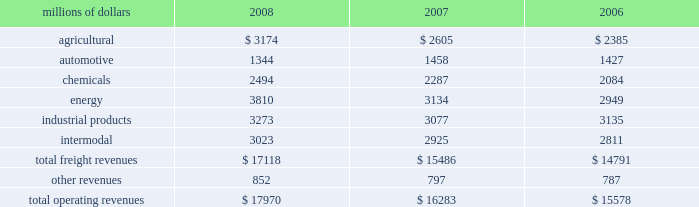Notes to the consolidated financial statements union pacific corporation and subsidiary companies for purposes of this report , unless the context otherwise requires , all references herein to the 201ccorporation 201d , 201cupc 201d , 201cwe 201d , 201cus 201d , and 201cour 201d mean union pacific corporation and its subsidiaries , including union pacific railroad company , which will be separately referred to herein as 201cuprr 201d or the 201crailroad 201d .
Nature of operations and significant accounting policies operations and segmentation 2013 we are a class i railroad that operates in the united states .
We have 32012 route miles , linking pacific coast and gulf coast ports with the midwest and eastern united states gateways and providing several corridors to key mexican gateways .
We serve the western two- thirds of the country and maintain coordinated schedules with other rail carriers for the handling of freight to and from the atlantic coast , the pacific coast , the southeast , the southwest , canada , and mexico .
Export and import traffic is moved through gulf coast and pacific coast ports and across the mexican and canadian borders .
The railroad , along with its subsidiaries and rail affiliates , is our one reportable operating segment .
Although revenues are analyzed by commodity group , we analyze the net financial results of the railroad as one segment due to the integrated nature of our rail network .
The table provides revenue by commodity group : millions of dollars 2008 2007 2006 .
Basis of presentation 2013 certain prior year amounts have been reclassified to conform to the current period financial statement presentation .
The reclassifications include reporting freight revenues instead of commodity revenues .
The amounts reclassified from freight revenues to other revenues totaled $ 30 million and $ 71 million for the years ended december 31 , 2007 , and december 31 , 2006 , respectively .
In addition , we modified our operating expense categories to report fuel used in railroad operations as a stand-alone category , to combine purchased services and materials into one line , and to reclassify certain other expenses among operating expense categories .
These reclassifications had no impact on previously reported operating revenues , total operating expenses , operating income or net income .
Significant accounting policies principles of consolidation 2013 the consolidated financial statements include the accounts of union pacific corporation and all of its subsidiaries .
Investments in affiliated companies ( 20% ( 20 % ) to 50% ( 50 % ) owned ) are accounted for using the equity method of accounting .
All significant intercompany transactions are eliminated .
The corporation evaluates its less than majority-owned investments for consolidation .
In 2006 what was the percent of other revenues re-classed from freight? 
Computations: (71 / 787)
Answer: 0.09022. 